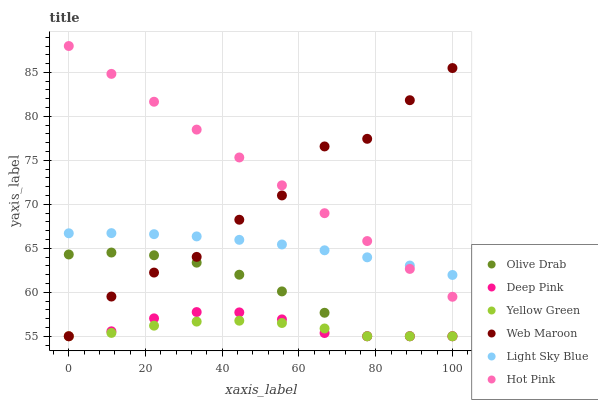Does Yellow Green have the minimum area under the curve?
Answer yes or no. Yes. Does Hot Pink have the maximum area under the curve?
Answer yes or no. Yes. Does Hot Pink have the minimum area under the curve?
Answer yes or no. No. Does Yellow Green have the maximum area under the curve?
Answer yes or no. No. Is Hot Pink the smoothest?
Answer yes or no. Yes. Is Web Maroon the roughest?
Answer yes or no. Yes. Is Yellow Green the smoothest?
Answer yes or no. No. Is Yellow Green the roughest?
Answer yes or no. No. Does Deep Pink have the lowest value?
Answer yes or no. Yes. Does Hot Pink have the lowest value?
Answer yes or no. No. Does Hot Pink have the highest value?
Answer yes or no. Yes. Does Yellow Green have the highest value?
Answer yes or no. No. Is Olive Drab less than Hot Pink?
Answer yes or no. Yes. Is Light Sky Blue greater than Olive Drab?
Answer yes or no. Yes. Does Light Sky Blue intersect Hot Pink?
Answer yes or no. Yes. Is Light Sky Blue less than Hot Pink?
Answer yes or no. No. Is Light Sky Blue greater than Hot Pink?
Answer yes or no. No. Does Olive Drab intersect Hot Pink?
Answer yes or no. No. 